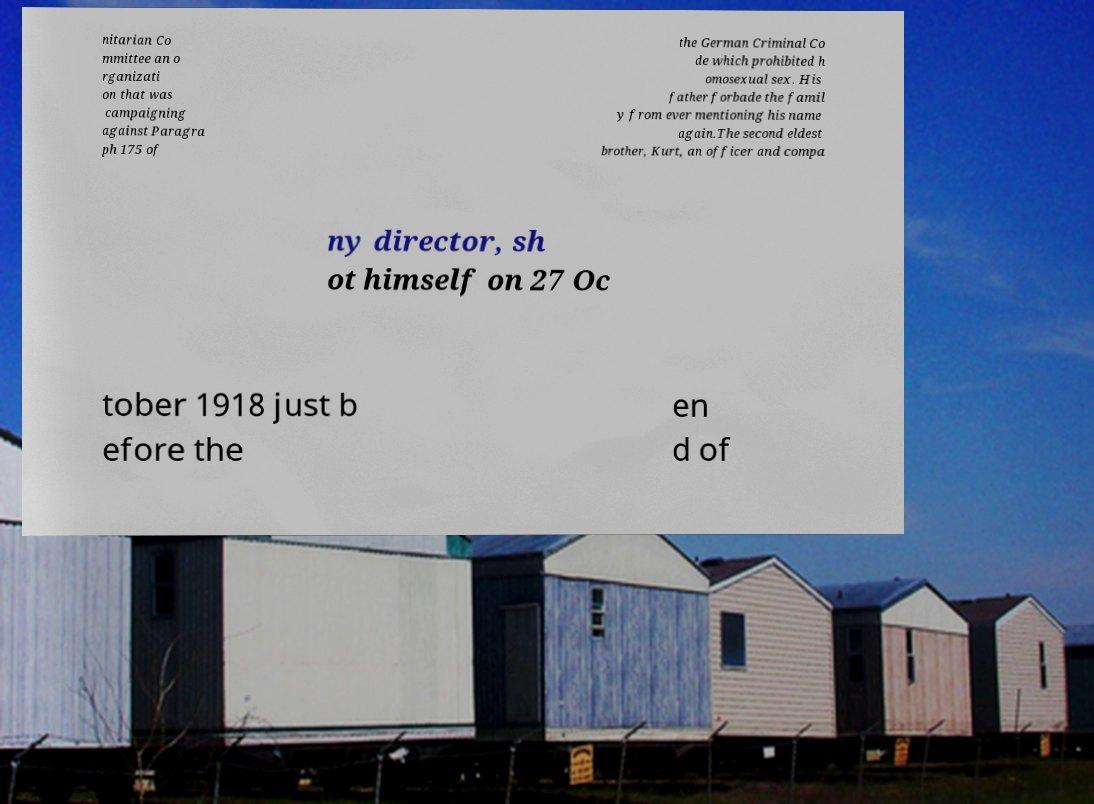Could you extract and type out the text from this image? nitarian Co mmittee an o rganizati on that was campaigning against Paragra ph 175 of the German Criminal Co de which prohibited h omosexual sex. His father forbade the famil y from ever mentioning his name again.The second eldest brother, Kurt, an officer and compa ny director, sh ot himself on 27 Oc tober 1918 just b efore the en d of 